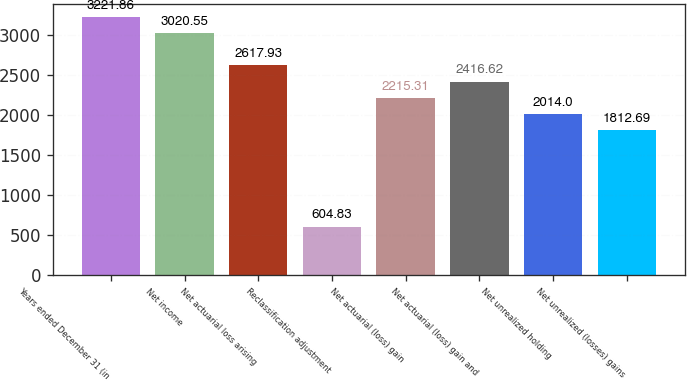Convert chart. <chart><loc_0><loc_0><loc_500><loc_500><bar_chart><fcel>Years ended December 31 (in<fcel>Net income<fcel>Net actuarial loss arising<fcel>Reclassification adjustment<fcel>Net actuarial (loss) gain<fcel>Net actuarial (loss) gain and<fcel>Net unrealized holding<fcel>Net unrealized (losses) gains<nl><fcel>3221.86<fcel>3020.55<fcel>2617.93<fcel>604.83<fcel>2215.31<fcel>2416.62<fcel>2014<fcel>1812.69<nl></chart> 